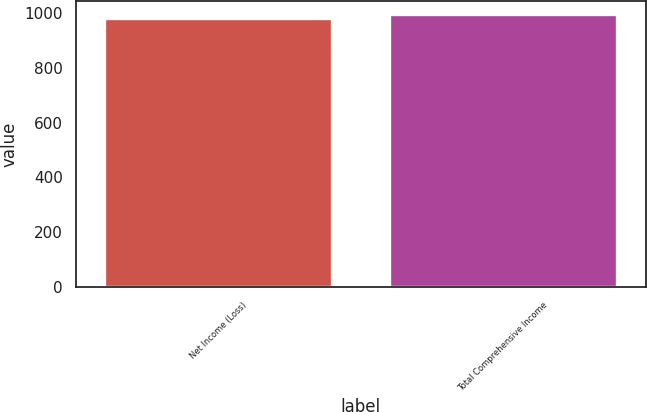<chart> <loc_0><loc_0><loc_500><loc_500><bar_chart><fcel>Net Income (Loss)<fcel>Total Comprehensive Income<nl><fcel>983<fcel>995<nl></chart> 